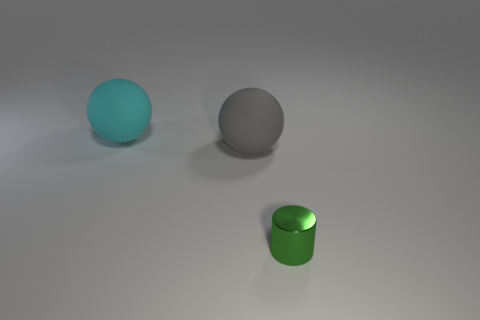Add 3 tiny brown rubber things. How many objects exist? 6 Subtract all cylinders. How many objects are left? 2 Subtract 0 brown spheres. How many objects are left? 3 Subtract all small objects. Subtract all metallic cylinders. How many objects are left? 1 Add 1 gray spheres. How many gray spheres are left? 2 Add 2 gray matte things. How many gray matte things exist? 3 